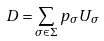Convert formula to latex. <formula><loc_0><loc_0><loc_500><loc_500>D = \sum _ { \sigma \in \Sigma } p _ { \sigma } U _ { \sigma }</formula> 